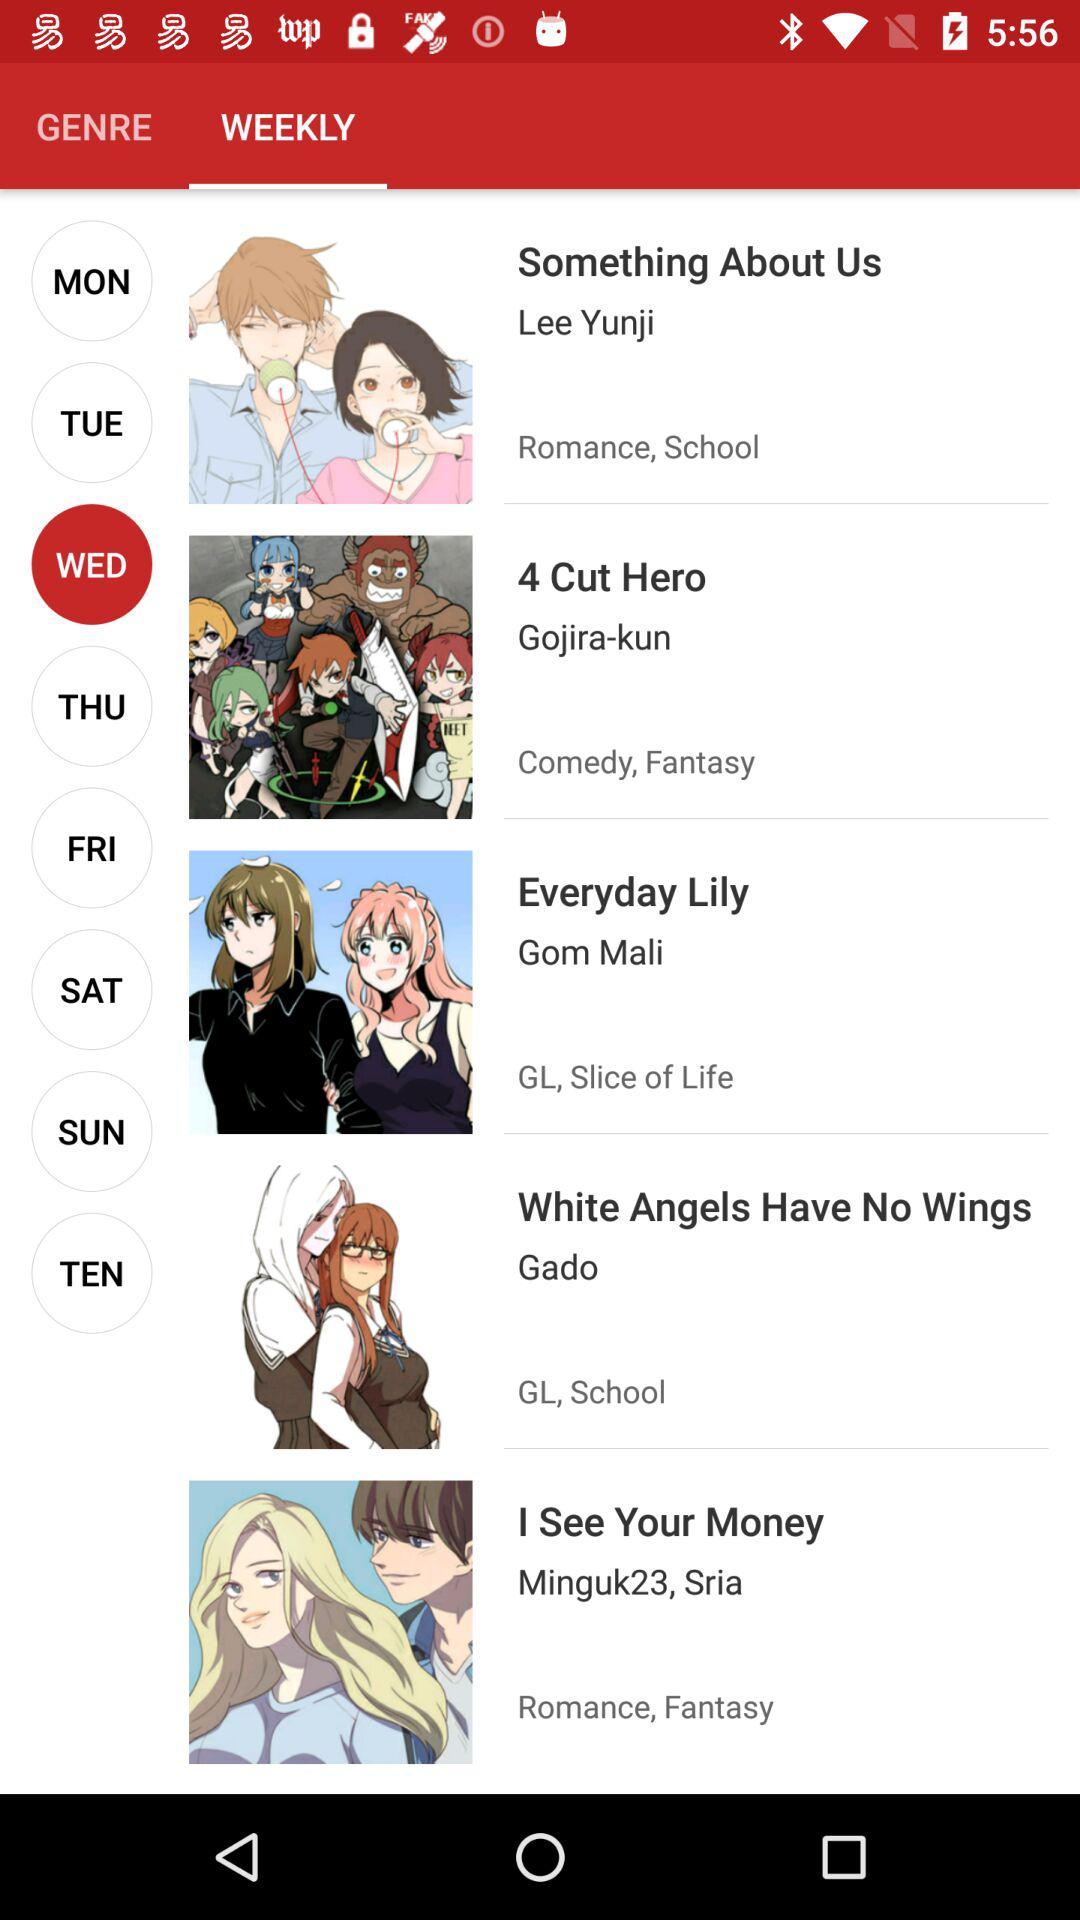Which tab am I using? You are using the "WEEKLY" tab. 